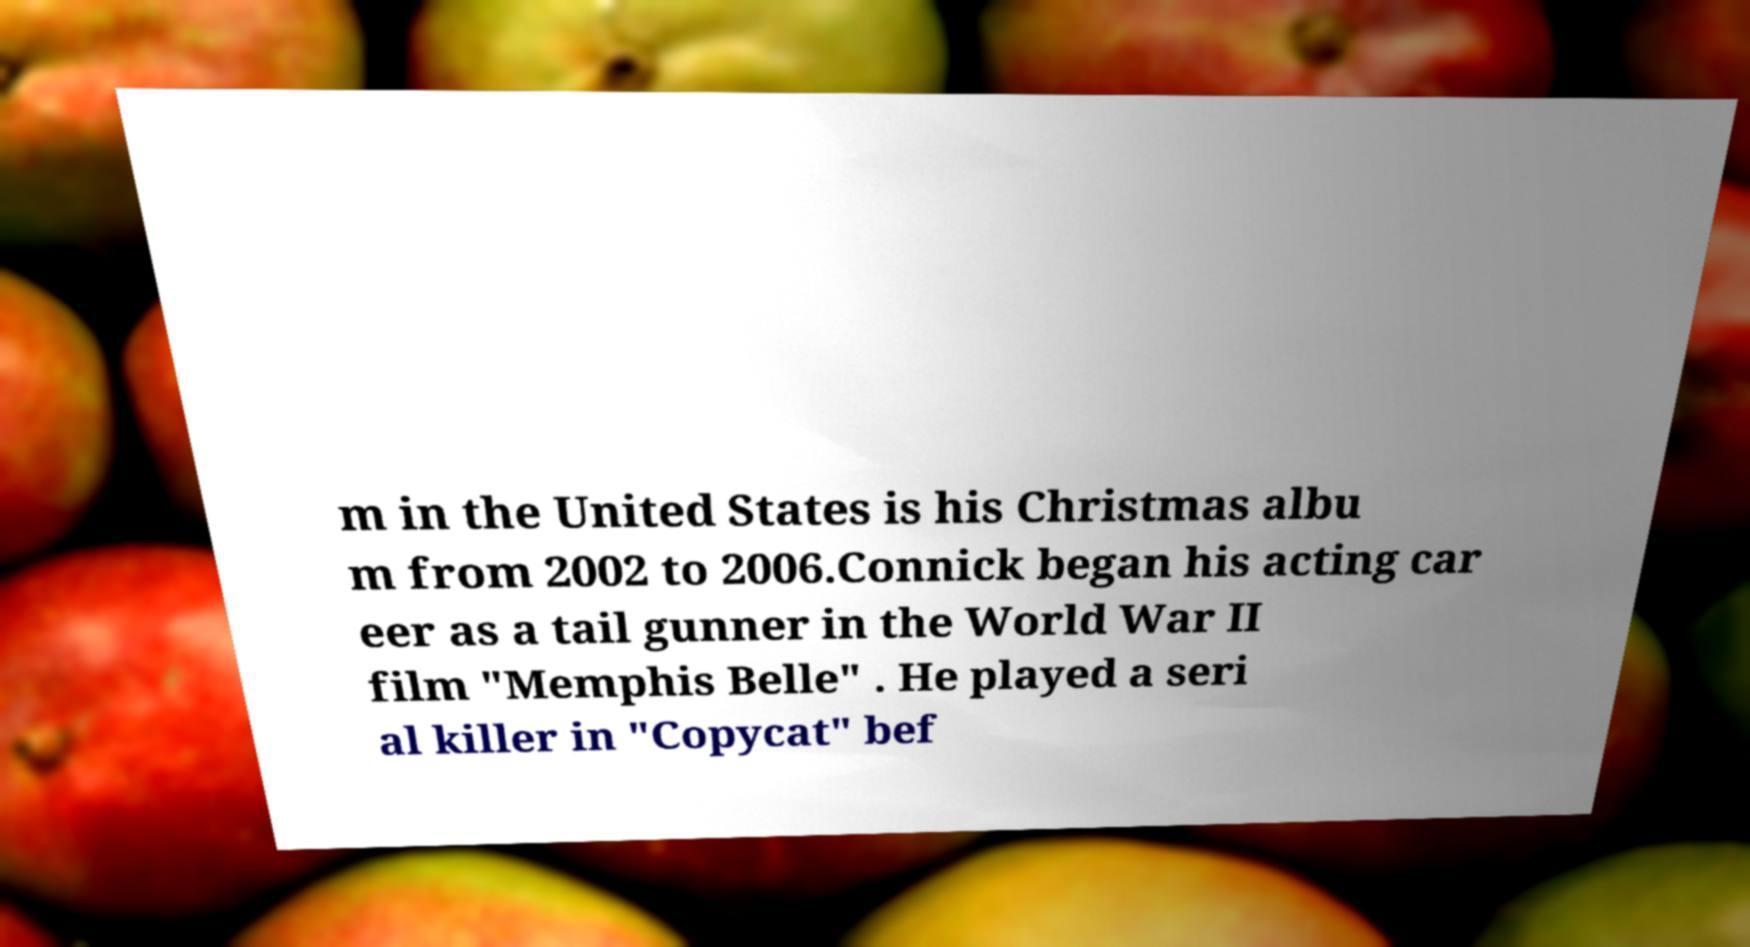What messages or text are displayed in this image? I need them in a readable, typed format. m in the United States is his Christmas albu m from 2002 to 2006.Connick began his acting car eer as a tail gunner in the World War II film "Memphis Belle" . He played a seri al killer in "Copycat" bef 